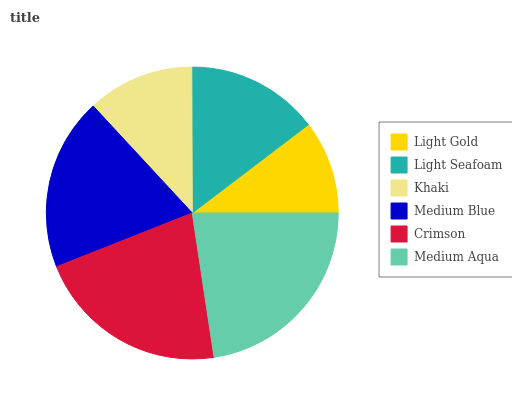Is Light Gold the minimum?
Answer yes or no. Yes. Is Medium Aqua the maximum?
Answer yes or no. Yes. Is Light Seafoam the minimum?
Answer yes or no. No. Is Light Seafoam the maximum?
Answer yes or no. No. Is Light Seafoam greater than Light Gold?
Answer yes or no. Yes. Is Light Gold less than Light Seafoam?
Answer yes or no. Yes. Is Light Gold greater than Light Seafoam?
Answer yes or no. No. Is Light Seafoam less than Light Gold?
Answer yes or no. No. Is Medium Blue the high median?
Answer yes or no. Yes. Is Light Seafoam the low median?
Answer yes or no. Yes. Is Medium Aqua the high median?
Answer yes or no. No. Is Medium Aqua the low median?
Answer yes or no. No. 